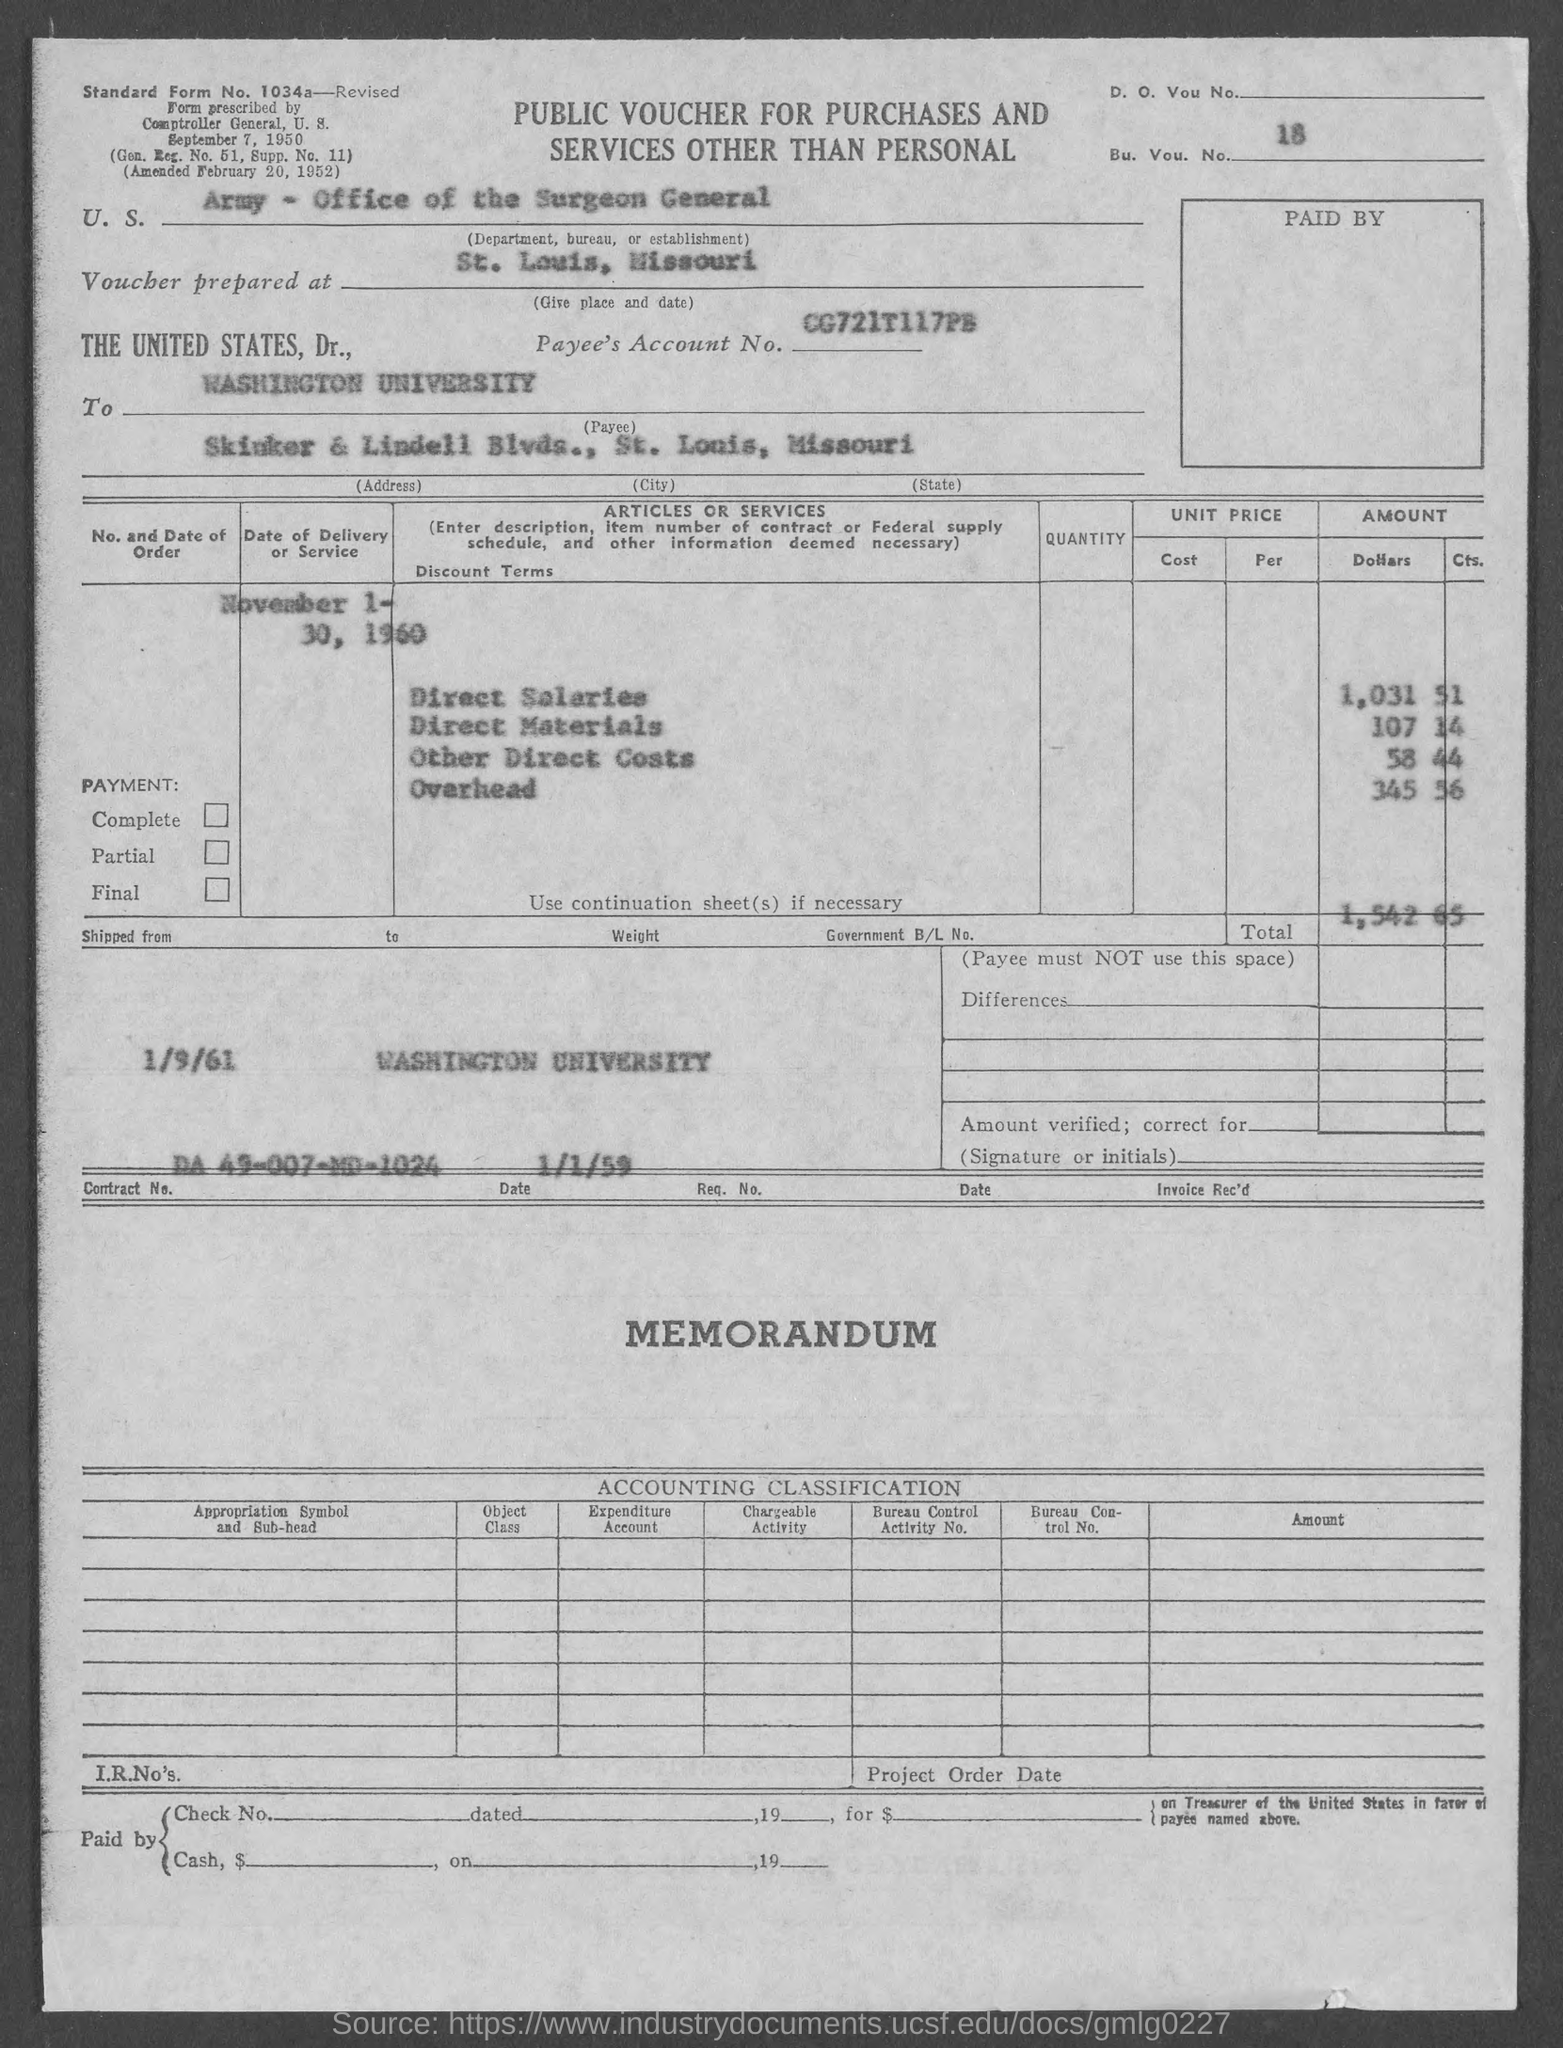Highlight a few significant elements in this photo. What is Supp. no. 11?" is a question that requires an answer to determine the meaning. Without additional context or information, it is unclear what the speaker is asking. The amount of other direct costs is 58.44. The total is 1,542 and 65 cents. Washington University is located in the state of Missouri. The amount of direct materials is 107.14. 